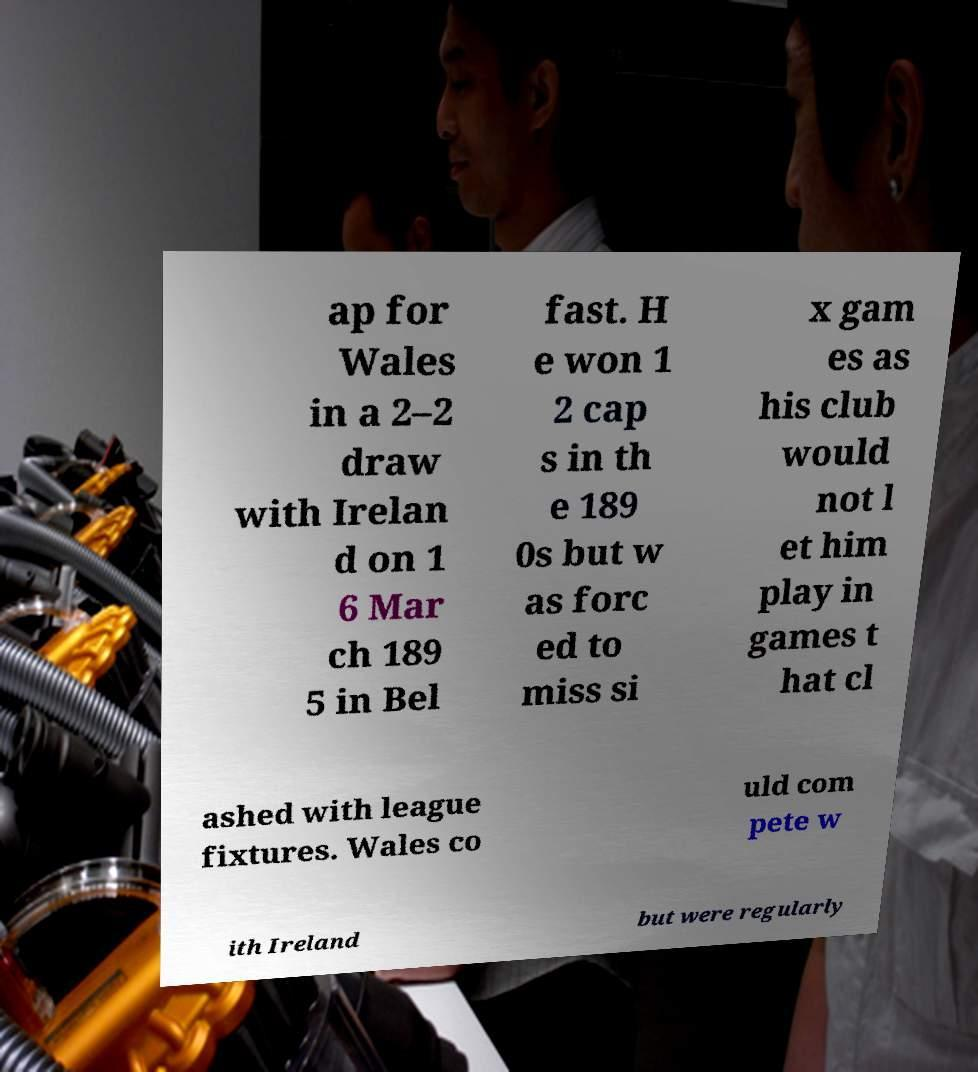What messages or text are displayed in this image? I need them in a readable, typed format. ap for Wales in a 2–2 draw with Irelan d on 1 6 Mar ch 189 5 in Bel fast. H e won 1 2 cap s in th e 189 0s but w as forc ed to miss si x gam es as his club would not l et him play in games t hat cl ashed with league fixtures. Wales co uld com pete w ith Ireland but were regularly 